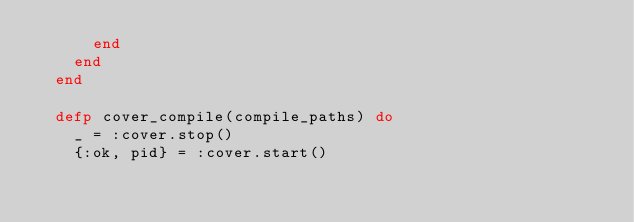<code> <loc_0><loc_0><loc_500><loc_500><_Elixir_>      end
    end
  end

  defp cover_compile(compile_paths) do
    _ = :cover.stop()
    {:ok, pid} = :cover.start()
</code> 